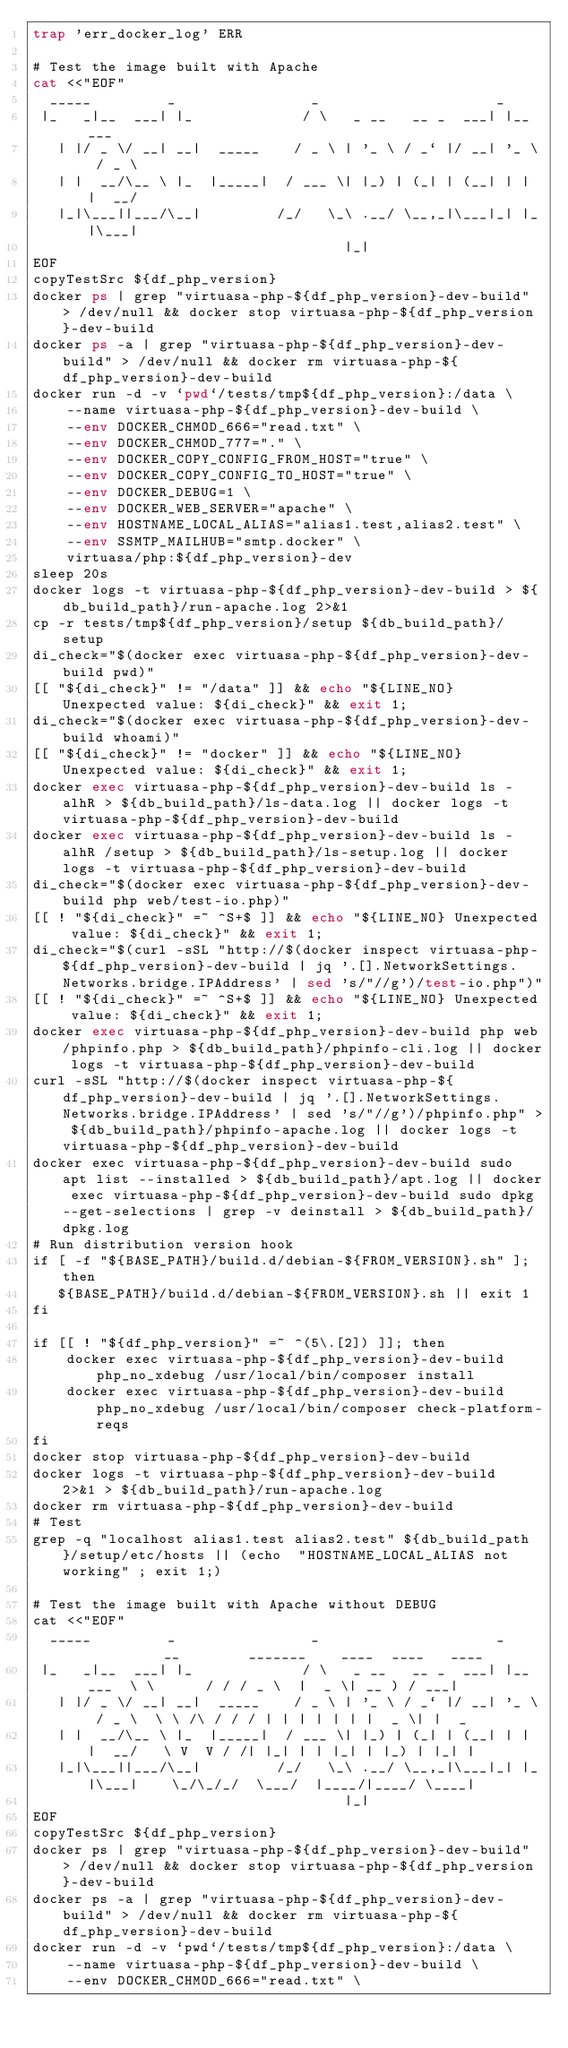<code> <loc_0><loc_0><loc_500><loc_500><_Bash_>trap 'err_docker_log' ERR

# Test the image built with Apache
cat <<"EOF"
  _____         _                _                     _
 |_   _|__  ___| |_             / \   _ __   __ _  ___| |__   ___
   | |/ _ \/ __| __|  _____    / _ \ | '_ \ / _` |/ __| '_ \ / _ \
   | |  __/\__ \ |_  |_____|  / ___ \| |_) | (_| | (__| | | |  __/
   |_|\___||___/\__|         /_/   \_\ .__/ \__,_|\___|_| |_|\___|
                                     |_|
EOF
copyTestSrc ${df_php_version}
docker ps | grep "virtuasa-php-${df_php_version}-dev-build" > /dev/null && docker stop virtuasa-php-${df_php_version}-dev-build
docker ps -a | grep "virtuasa-php-${df_php_version}-dev-build" > /dev/null && docker rm virtuasa-php-${df_php_version}-dev-build
docker run -d -v `pwd`/tests/tmp${df_php_version}:/data \
    --name virtuasa-php-${df_php_version}-dev-build \
    --env DOCKER_CHMOD_666="read.txt" \
    --env DOCKER_CHMOD_777="." \
    --env DOCKER_COPY_CONFIG_FROM_HOST="true" \
    --env DOCKER_COPY_CONFIG_TO_HOST="true" \
    --env DOCKER_DEBUG=1 \
    --env DOCKER_WEB_SERVER="apache" \
    --env HOSTNAME_LOCAL_ALIAS="alias1.test,alias2.test" \
    --env SSMTP_MAILHUB="smtp.docker" \
    virtuasa/php:${df_php_version}-dev
sleep 20s
docker logs -t virtuasa-php-${df_php_version}-dev-build > ${db_build_path}/run-apache.log 2>&1
cp -r tests/tmp${df_php_version}/setup ${db_build_path}/setup
di_check="$(docker exec virtuasa-php-${df_php_version}-dev-build pwd)"
[[ "${di_check}" != "/data" ]] && echo "${LINE_NO} Unexpected value: ${di_check}" && exit 1;
di_check="$(docker exec virtuasa-php-${df_php_version}-dev-build whoami)"
[[ "${di_check}" != "docker" ]] && echo "${LINE_NO} Unexpected value: ${di_check}" && exit 1;
docker exec virtuasa-php-${df_php_version}-dev-build ls -alhR > ${db_build_path}/ls-data.log || docker logs -t virtuasa-php-${df_php_version}-dev-build
docker exec virtuasa-php-${df_php_version}-dev-build ls -alhR /setup > ${db_build_path}/ls-setup.log || docker logs -t virtuasa-php-${df_php_version}-dev-build
di_check="$(docker exec virtuasa-php-${df_php_version}-dev-build php web/test-io.php)"
[[ ! "${di_check}" =~ ^S+$ ]] && echo "${LINE_NO} Unexpected value: ${di_check}" && exit 1;
di_check="$(curl -sSL "http://$(docker inspect virtuasa-php-${df_php_version}-dev-build | jq '.[].NetworkSettings.Networks.bridge.IPAddress' | sed 's/"//g')/test-io.php")"
[[ ! "${di_check}" =~ ^S+$ ]] && echo "${LINE_NO} Unexpected value: ${di_check}" && exit 1;
docker exec virtuasa-php-${df_php_version}-dev-build php web/phpinfo.php > ${db_build_path}/phpinfo-cli.log || docker logs -t virtuasa-php-${df_php_version}-dev-build
curl -sSL "http://$(docker inspect virtuasa-php-${df_php_version}-dev-build | jq '.[].NetworkSettings.Networks.bridge.IPAddress' | sed 's/"//g')/phpinfo.php" > ${db_build_path}/phpinfo-apache.log || docker logs -t virtuasa-php-${df_php_version}-dev-build
docker exec virtuasa-php-${df_php_version}-dev-build sudo apt list --installed > ${db_build_path}/apt.log || docker exec virtuasa-php-${df_php_version}-dev-build sudo dpkg --get-selections | grep -v deinstall > ${db_build_path}/dpkg.log
# Run distribution version hook
if [ -f "${BASE_PATH}/build.d/debian-${FROM_VERSION}.sh" ]; then
   ${BASE_PATH}/build.d/debian-${FROM_VERSION}.sh || exit 1
fi

if [[ ! "${df_php_version}" =~ ^(5\.[2]) ]]; then
    docker exec virtuasa-php-${df_php_version}-dev-build php_no_xdebug /usr/local/bin/composer install
    docker exec virtuasa-php-${df_php_version}-dev-build php_no_xdebug /usr/local/bin/composer check-platform-reqs
fi
docker stop virtuasa-php-${df_php_version}-dev-build
docker logs -t virtuasa-php-${df_php_version}-dev-build  2>&1 > ${db_build_path}/run-apache.log
docker rm virtuasa-php-${df_php_version}-dev-build
# Test
grep -q "localhost alias1.test alias2.test" ${db_build_path}/setup/etc/hosts || (echo  "HOSTNAME_LOCAL_ALIAS not working" ; exit 1;)

# Test the image built with Apache without DEBUG
cat <<"EOF"
  _____         _                _                     _           __        _______    ____  ____   ____
 |_   _|__  ___| |_             / \   _ __   __ _  ___| |__   ___  \ \      / / / _ \  |  _ \| __ ) / ___|
   | |/ _ \/ __| __|  _____    / _ \ | '_ \ / _` |/ __| '_ \ / _ \  \ \ /\ / / / | | | | | | |  _ \| |  _
   | |  __/\__ \ |_  |_____|  / ___ \| |_) | (_| | (__| | | |  __/   \ V  V / /| |_| | | |_| | |_) | |_| |
   |_|\___||___/\__|         /_/   \_\ .__/ \__,_|\___|_| |_|\___|    \_/\_/_/  \___/  |____/|____/ \____|
                                     |_|
EOF
copyTestSrc ${df_php_version}
docker ps | grep "virtuasa-php-${df_php_version}-dev-build" > /dev/null && docker stop virtuasa-php-${df_php_version}-dev-build
docker ps -a | grep "virtuasa-php-${df_php_version}-dev-build" > /dev/null && docker rm virtuasa-php-${df_php_version}-dev-build
docker run -d -v `pwd`/tests/tmp${df_php_version}:/data \
    --name virtuasa-php-${df_php_version}-dev-build \
    --env DOCKER_CHMOD_666="read.txt" \</code> 